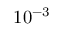Convert formula to latex. <formula><loc_0><loc_0><loc_500><loc_500>1 0 ^ { - 3 }</formula> 